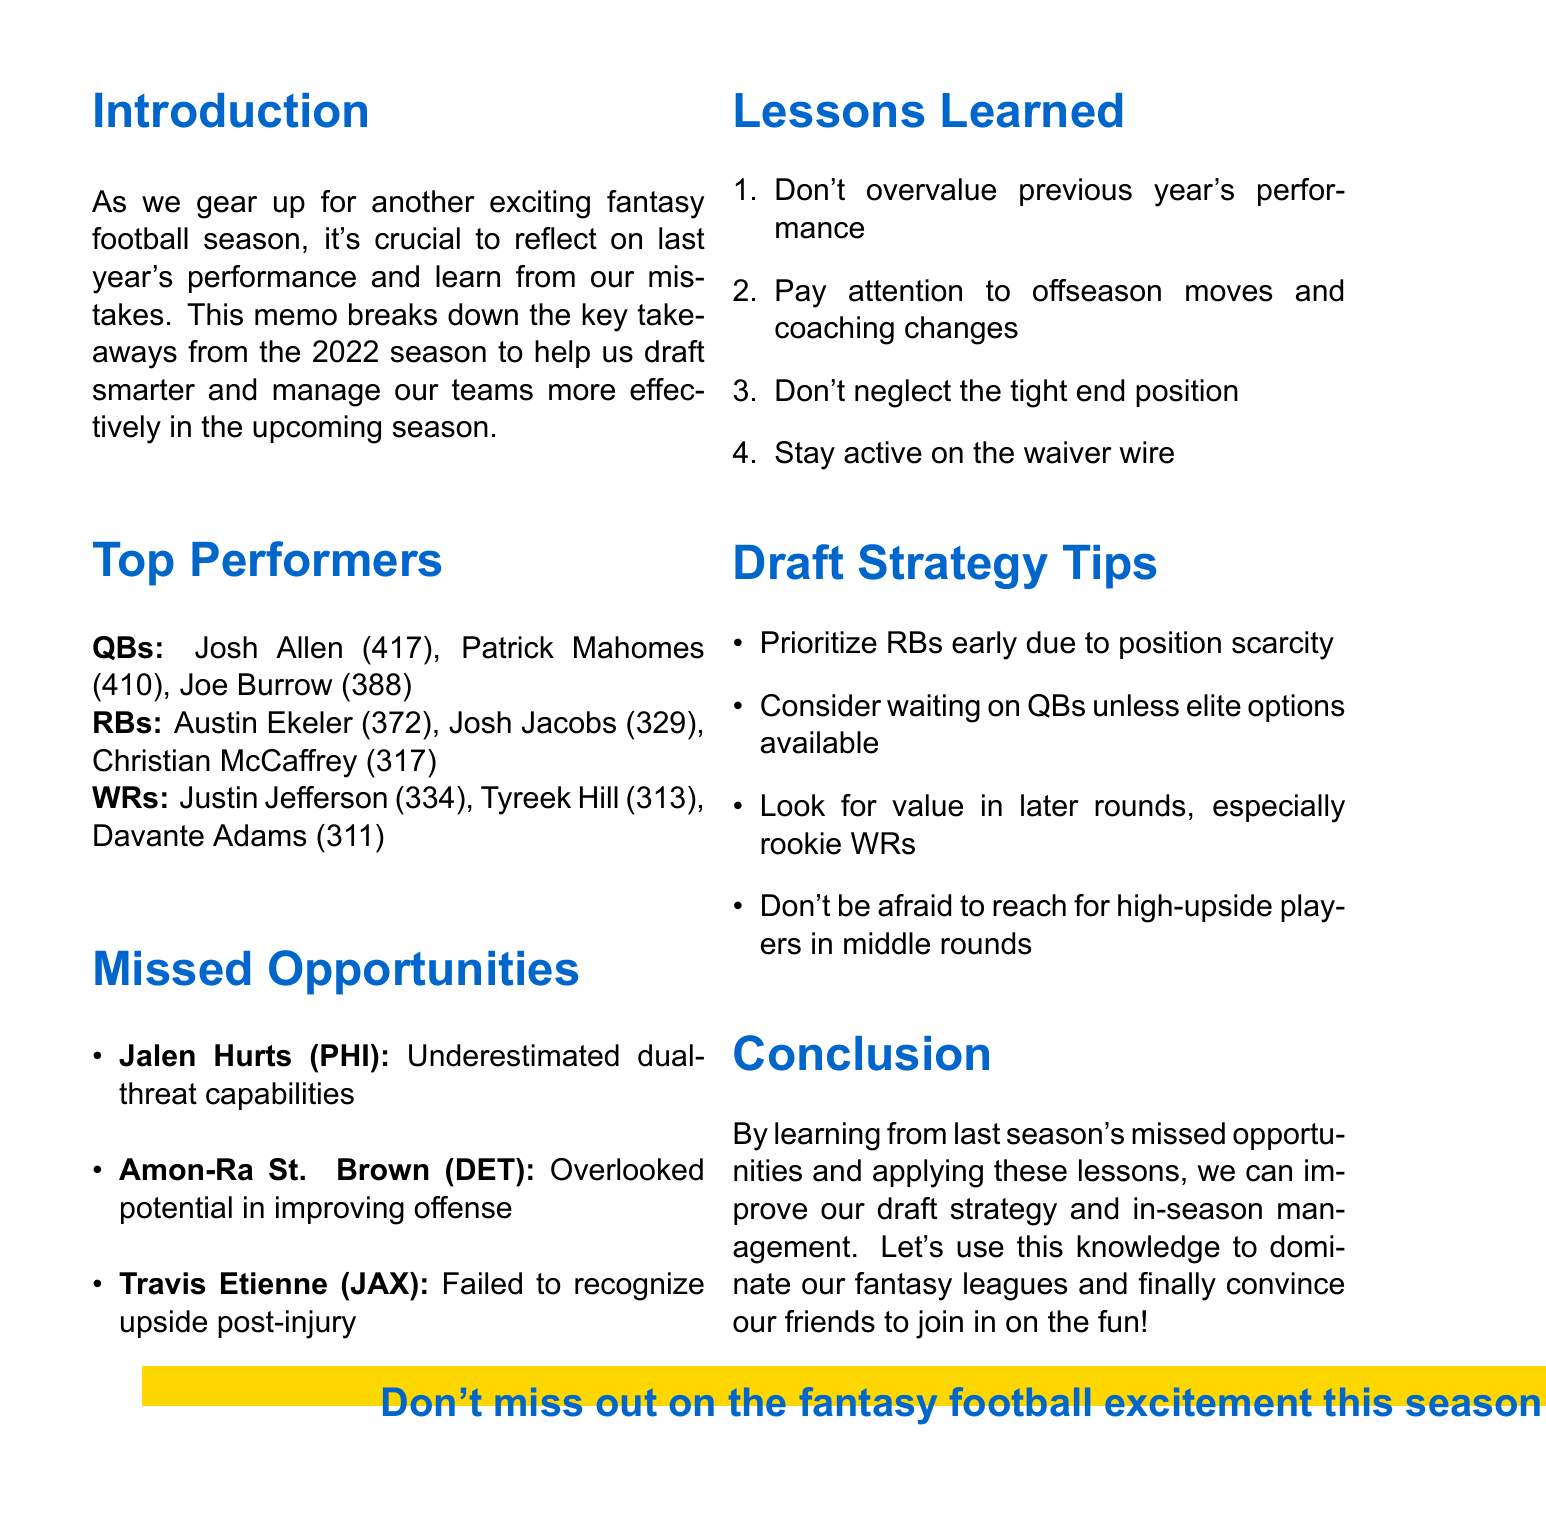What were the top scoring quarterbacks of the 2022 season? The document lists Josh Allen, Patrick Mahomes, and Joe Burrow as the top quarterbacks based on their points scored.
Answer: Josh Allen, Patrick Mahomes, Joe Burrow How many points did Austin Ekeler score in the last season? The document provides a total of points for running backs, listing Austin Ekeler with 372 points.
Answer: 372 Who is mentioned as a missed opportunity due to underestimated dual-threat capabilities? The document explicitly states Jalen Hurts was a missed opportunity for not recognizing his dual-threat capabilities.
Answer: Jalen Hurts What is one of the lessons learned regarding player performance? The document mentions that one lesson learned is not to overvalue previous year's performance for drafting players.
Answer: Don't overvalue previous year's performance Which position should be prioritized early in the draft according to the draft strategy tips? The document advises prioritizing running backs early due to their position scarcity.
Answer: Running backs 